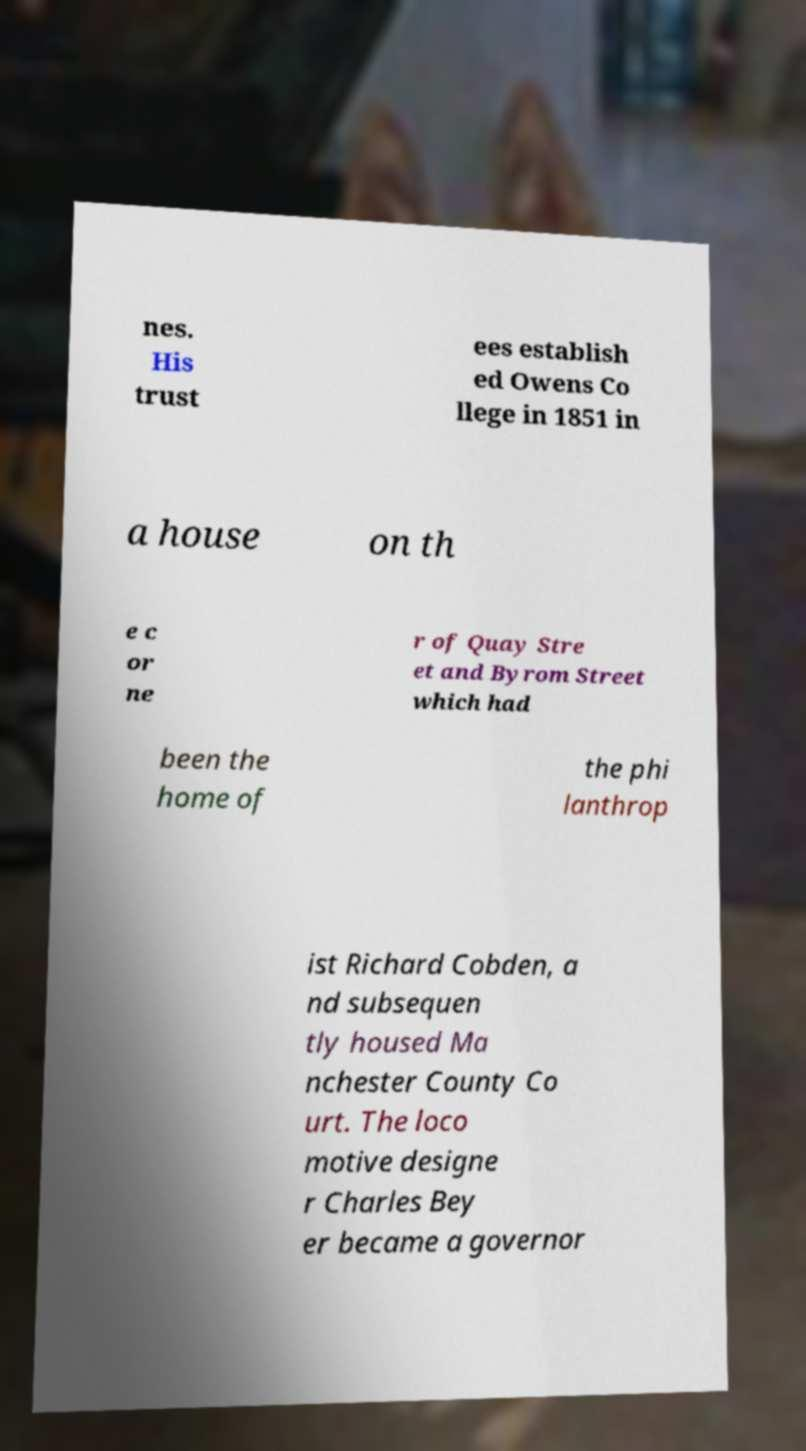Please read and relay the text visible in this image. What does it say? nes. His trust ees establish ed Owens Co llege in 1851 in a house on th e c or ne r of Quay Stre et and Byrom Street which had been the home of the phi lanthrop ist Richard Cobden, a nd subsequen tly housed Ma nchester County Co urt. The loco motive designe r Charles Bey er became a governor 